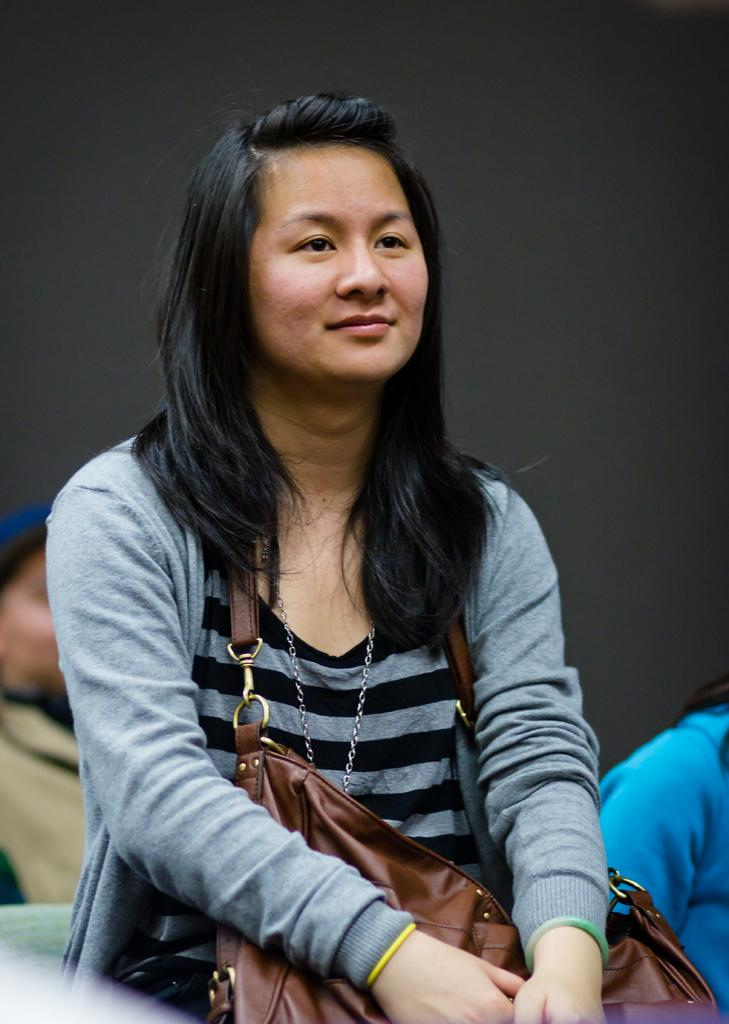Who is the main subject in the image? There is a woman in the middle of the image. Are there any other people visible in the image? Yes, there are other persons at the bottom of the image. What can be seen in the background of the image? There is a wall in the background of the image. What type of yarn is the woman using in the image? There is no yarn present in the image; the woman is not holding or using any yarn. 